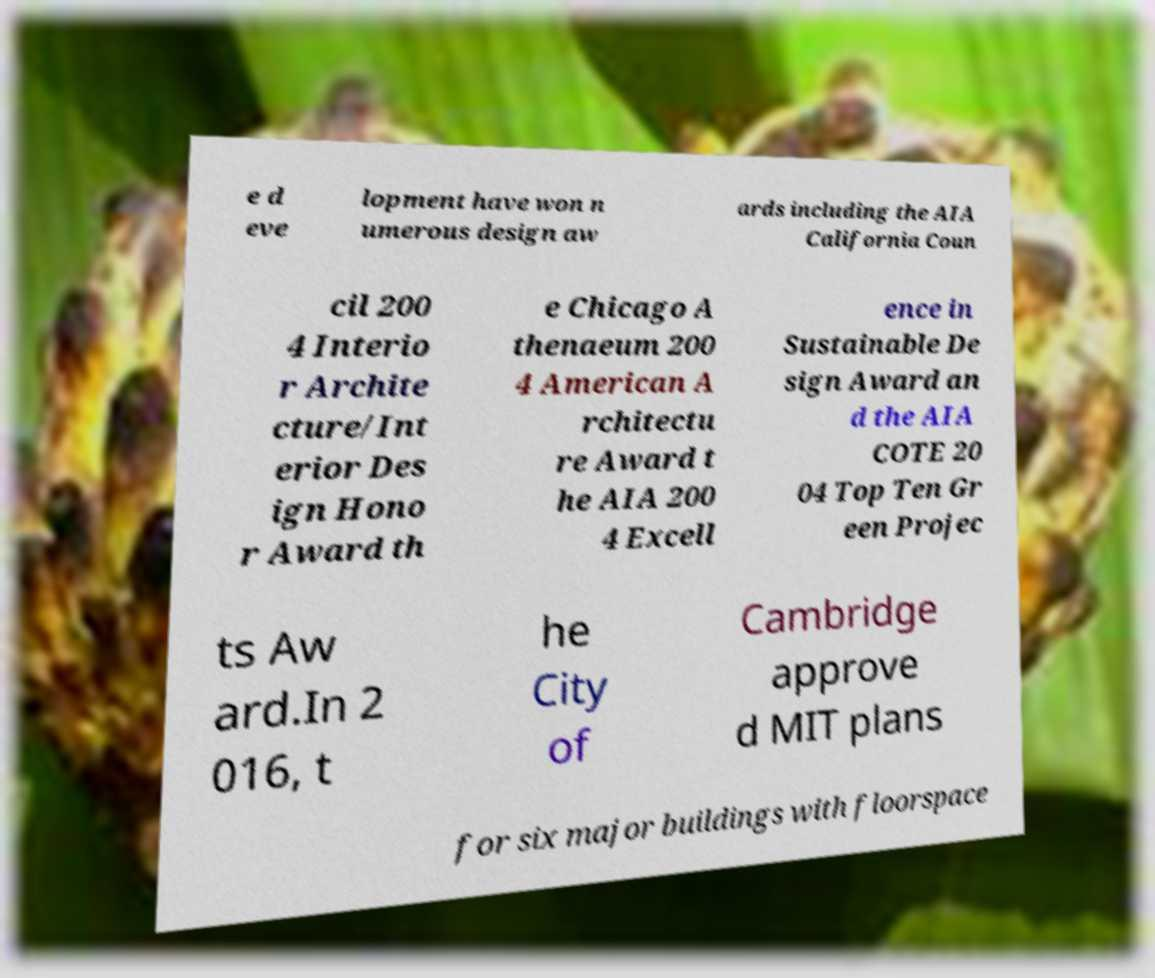For documentation purposes, I need the text within this image transcribed. Could you provide that? e d eve lopment have won n umerous design aw ards including the AIA California Coun cil 200 4 Interio r Archite cture/Int erior Des ign Hono r Award th e Chicago A thenaeum 200 4 American A rchitectu re Award t he AIA 200 4 Excell ence in Sustainable De sign Award an d the AIA COTE 20 04 Top Ten Gr een Projec ts Aw ard.In 2 016, t he City of Cambridge approve d MIT plans for six major buildings with floorspace 